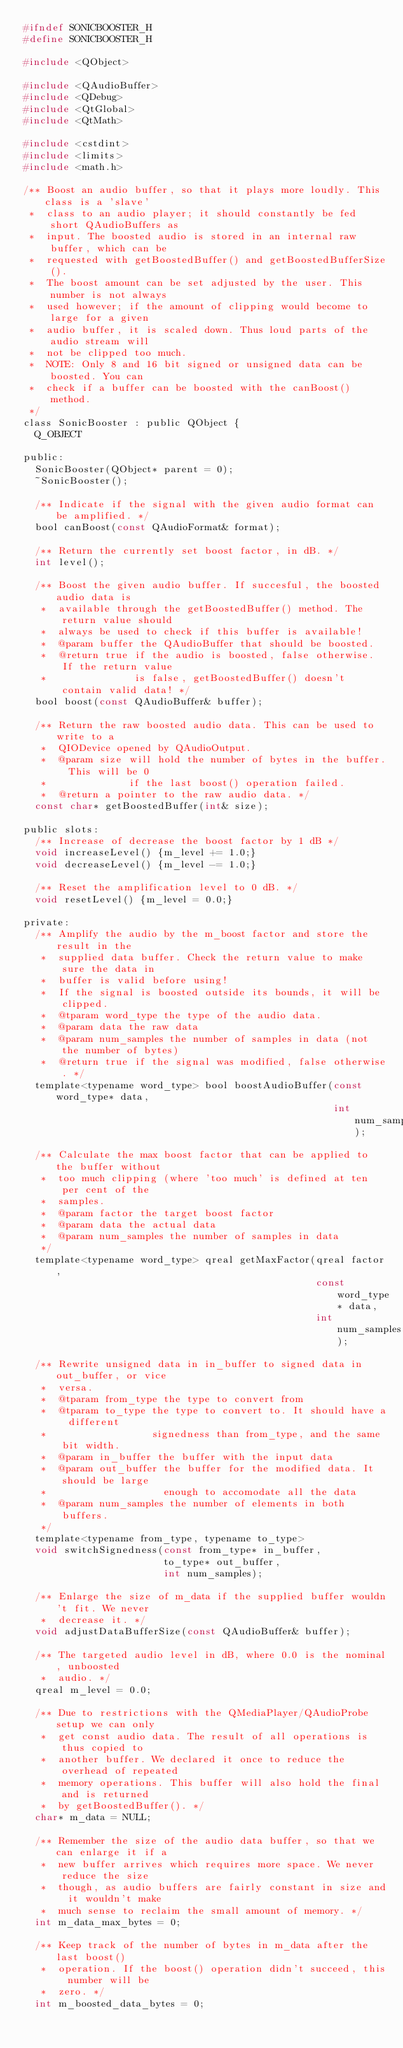Convert code to text. <code><loc_0><loc_0><loc_500><loc_500><_C_>#ifndef SONICBOOSTER_H
#define SONICBOOSTER_H

#include <QObject>

#include <QAudioBuffer>
#include <QDebug>
#include <QtGlobal>
#include <QtMath>

#include <cstdint>
#include <limits>
#include <math.h>

/** Boost an audio buffer, so that it plays more loudly. This class is a 'slave'
 *  class to an audio player; it should constantly be fed short QAudioBuffers as
 *  input. The boosted audio is stored in an internal raw buffer, which can be
 *  requested with getBoostedBuffer() and getBoostedBufferSize().
 *  The boost amount can be set adjusted by the user. This number is not always
 *  used however; if the amount of clipping would become to large for a given
 *  audio buffer, it is scaled down. Thus loud parts of the audio stream will
 *  not be clipped too much.
 *  NOTE: Only 8 and 16 bit signed or unsigned data can be boosted. You can
 *  check if a buffer can be boosted with the canBoost() method.
 */
class SonicBooster : public QObject {
  Q_OBJECT

public:
  SonicBooster(QObject* parent = 0);
  ~SonicBooster();

  /** Indicate if the signal with the given audio format can be amplified. */
  bool canBoost(const QAudioFormat& format);

  /** Return the currently set boost factor, in dB. */
  int level();

  /** Boost the given audio buffer. If succesful, the boosted audio data is
   *  available through the getBoostedBuffer() method. The return value should
   *  always be used to check if this buffer is available!
   *  @param buffer the QAudioBuffer that should be boosted.
   *  @return true if the audio is boosted, false otherwise. If the return value
   *               is false, getBoostedBuffer() doesn't contain valid data! */
  bool boost(const QAudioBuffer& buffer);

  /** Return the raw boosted audio data. This can be used to write to a
   *  QIODevice opened by QAudioOutput.
   *  @param size will hold the number of bytes in the buffer. This will be 0
   *              if the last boost() operation failed.
   *  @return a pointer to the raw audio data. */
  const char* getBoostedBuffer(int& size);

public slots:
  /** Increase of decrease the boost factor by 1 dB */
  void increaseLevel() {m_level += 1.0;}
  void decreaseLevel() {m_level -= 1.0;}

  /** Reset the amplification level to 0 dB. */
  void resetLevel() {m_level = 0.0;}

private:
  /** Amplify the audio by the m_boost factor and store the result in the
   *  supplied data buffer. Check the return value to make sure the data in
   *  buffer is valid before using!
   *  If the signal is boosted outside its bounds, it will be clipped.
   *  @tparam word_type the type of the audio data.
   *  @param data the raw data
   *  @param num_samples the number of samples in data (not the number of bytes)
   *  @return true if the signal was modified, false otherwise. */
  template<typename word_type> bool boostAudioBuffer(const word_type* data,
                                                     int num_samples);

  /** Calculate the max boost factor that can be applied to the buffer without
   *  too much clipping (where 'too much' is defined at ten per cent of the
   *  samples.
   *  @param factor the target boost factor
   *  @param data the actual data
   *  @param num_samples the number of samples in data
   */
  template<typename word_type> qreal getMaxFactor(qreal factor,
                                                  const word_type* data,
                                                  int num_samples);

  /** Rewrite unsigned data in in_buffer to signed data in out_buffer, or vice
   *  versa.
   *  @tparam from_type the type to convert from
   *  @tparam to_type the type to convert to. It should have a different
   *                  signedness than from_type, and the same bit width.
   *  @param in_buffer the buffer with the input data
   *  @param out_buffer the buffer for the modified data. It should be large
   *                    enough to accomodate all the data
   *  @param num_samples the number of elements in both buffers.
   */
  template<typename from_type, typename to_type>
  void switchSignedness(const from_type* in_buffer,
                        to_type* out_buffer,
                        int num_samples);

  /** Enlarge the size of m_data if the supplied buffer wouldn't fit. We never
   *  decrease it. */
  void adjustDataBufferSize(const QAudioBuffer& buffer);

  /** The targeted audio level in dB, where 0.0 is the nominal, unboosted
   *  audio. */
  qreal m_level = 0.0;

  /** Due to restrictions with the QMediaPlayer/QAudioProbe setup we can only
   *  get const audio data. The result of all operations is thus copied to
   *  another buffer. We declared it once to reduce the overhead of repeated
   *  memory operations. This buffer will also hold the final and is returned
   *  by getBoostedBuffer(). */
  char* m_data = NULL;

  /** Remember the size of the audio data buffer, so that we can enlarge it if a
   *  new buffer arrives which requires more space. We never reduce the size
   *  though, as audio buffers are fairly constant in size and it wouldn't make
   *  much sense to reclaim the small amount of memory. */
  int m_data_max_bytes = 0;

  /** Keep track of the number of bytes in m_data after the last boost()
   *  operation. If the boost() operation didn't succeed, this number will be
   *  zero. */
  int m_boosted_data_bytes = 0;
</code> 